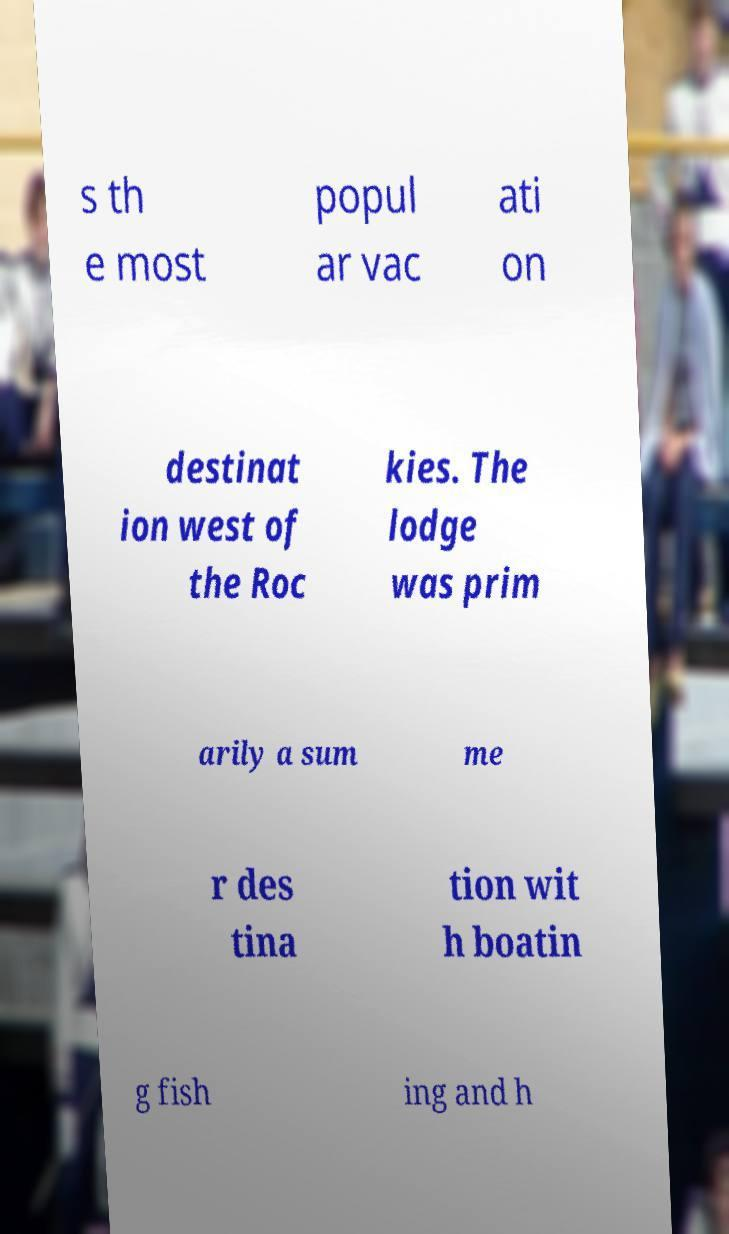Can you read and provide the text displayed in the image?This photo seems to have some interesting text. Can you extract and type it out for me? s th e most popul ar vac ati on destinat ion west of the Roc kies. The lodge was prim arily a sum me r des tina tion wit h boatin g fish ing and h 